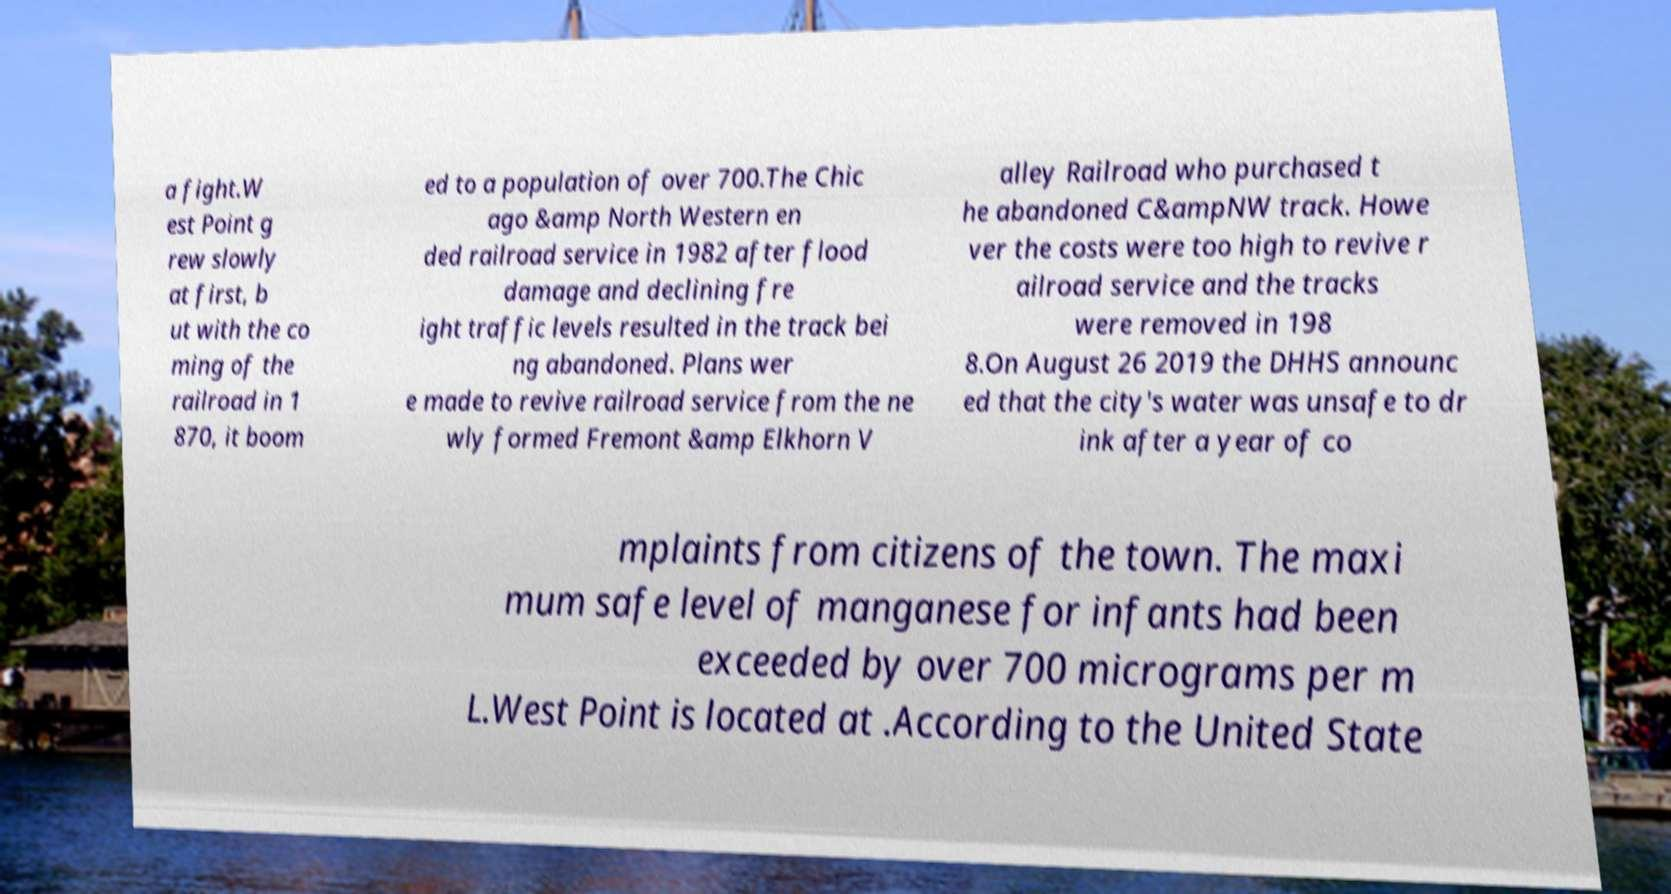What messages or text are displayed in this image? I need them in a readable, typed format. a fight.W est Point g rew slowly at first, b ut with the co ming of the railroad in 1 870, it boom ed to a population of over 700.The Chic ago &amp North Western en ded railroad service in 1982 after flood damage and declining fre ight traffic levels resulted in the track bei ng abandoned. Plans wer e made to revive railroad service from the ne wly formed Fremont &amp Elkhorn V alley Railroad who purchased t he abandoned C&ampNW track. Howe ver the costs were too high to revive r ailroad service and the tracks were removed in 198 8.On August 26 2019 the DHHS announc ed that the city's water was unsafe to dr ink after a year of co mplaints from citizens of the town. The maxi mum safe level of manganese for infants had been exceeded by over 700 micrograms per m L.West Point is located at .According to the United State 